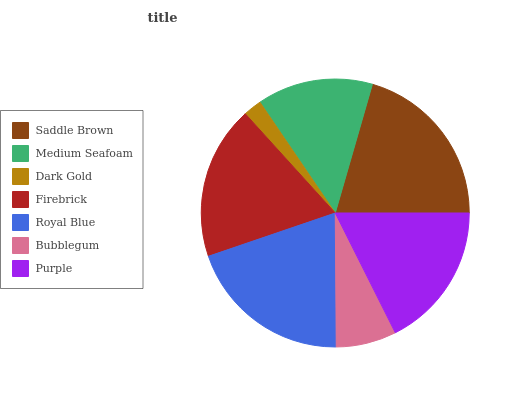Is Dark Gold the minimum?
Answer yes or no. Yes. Is Saddle Brown the maximum?
Answer yes or no. Yes. Is Medium Seafoam the minimum?
Answer yes or no. No. Is Medium Seafoam the maximum?
Answer yes or no. No. Is Saddle Brown greater than Medium Seafoam?
Answer yes or no. Yes. Is Medium Seafoam less than Saddle Brown?
Answer yes or no. Yes. Is Medium Seafoam greater than Saddle Brown?
Answer yes or no. No. Is Saddle Brown less than Medium Seafoam?
Answer yes or no. No. Is Purple the high median?
Answer yes or no. Yes. Is Purple the low median?
Answer yes or no. Yes. Is Firebrick the high median?
Answer yes or no. No. Is Firebrick the low median?
Answer yes or no. No. 